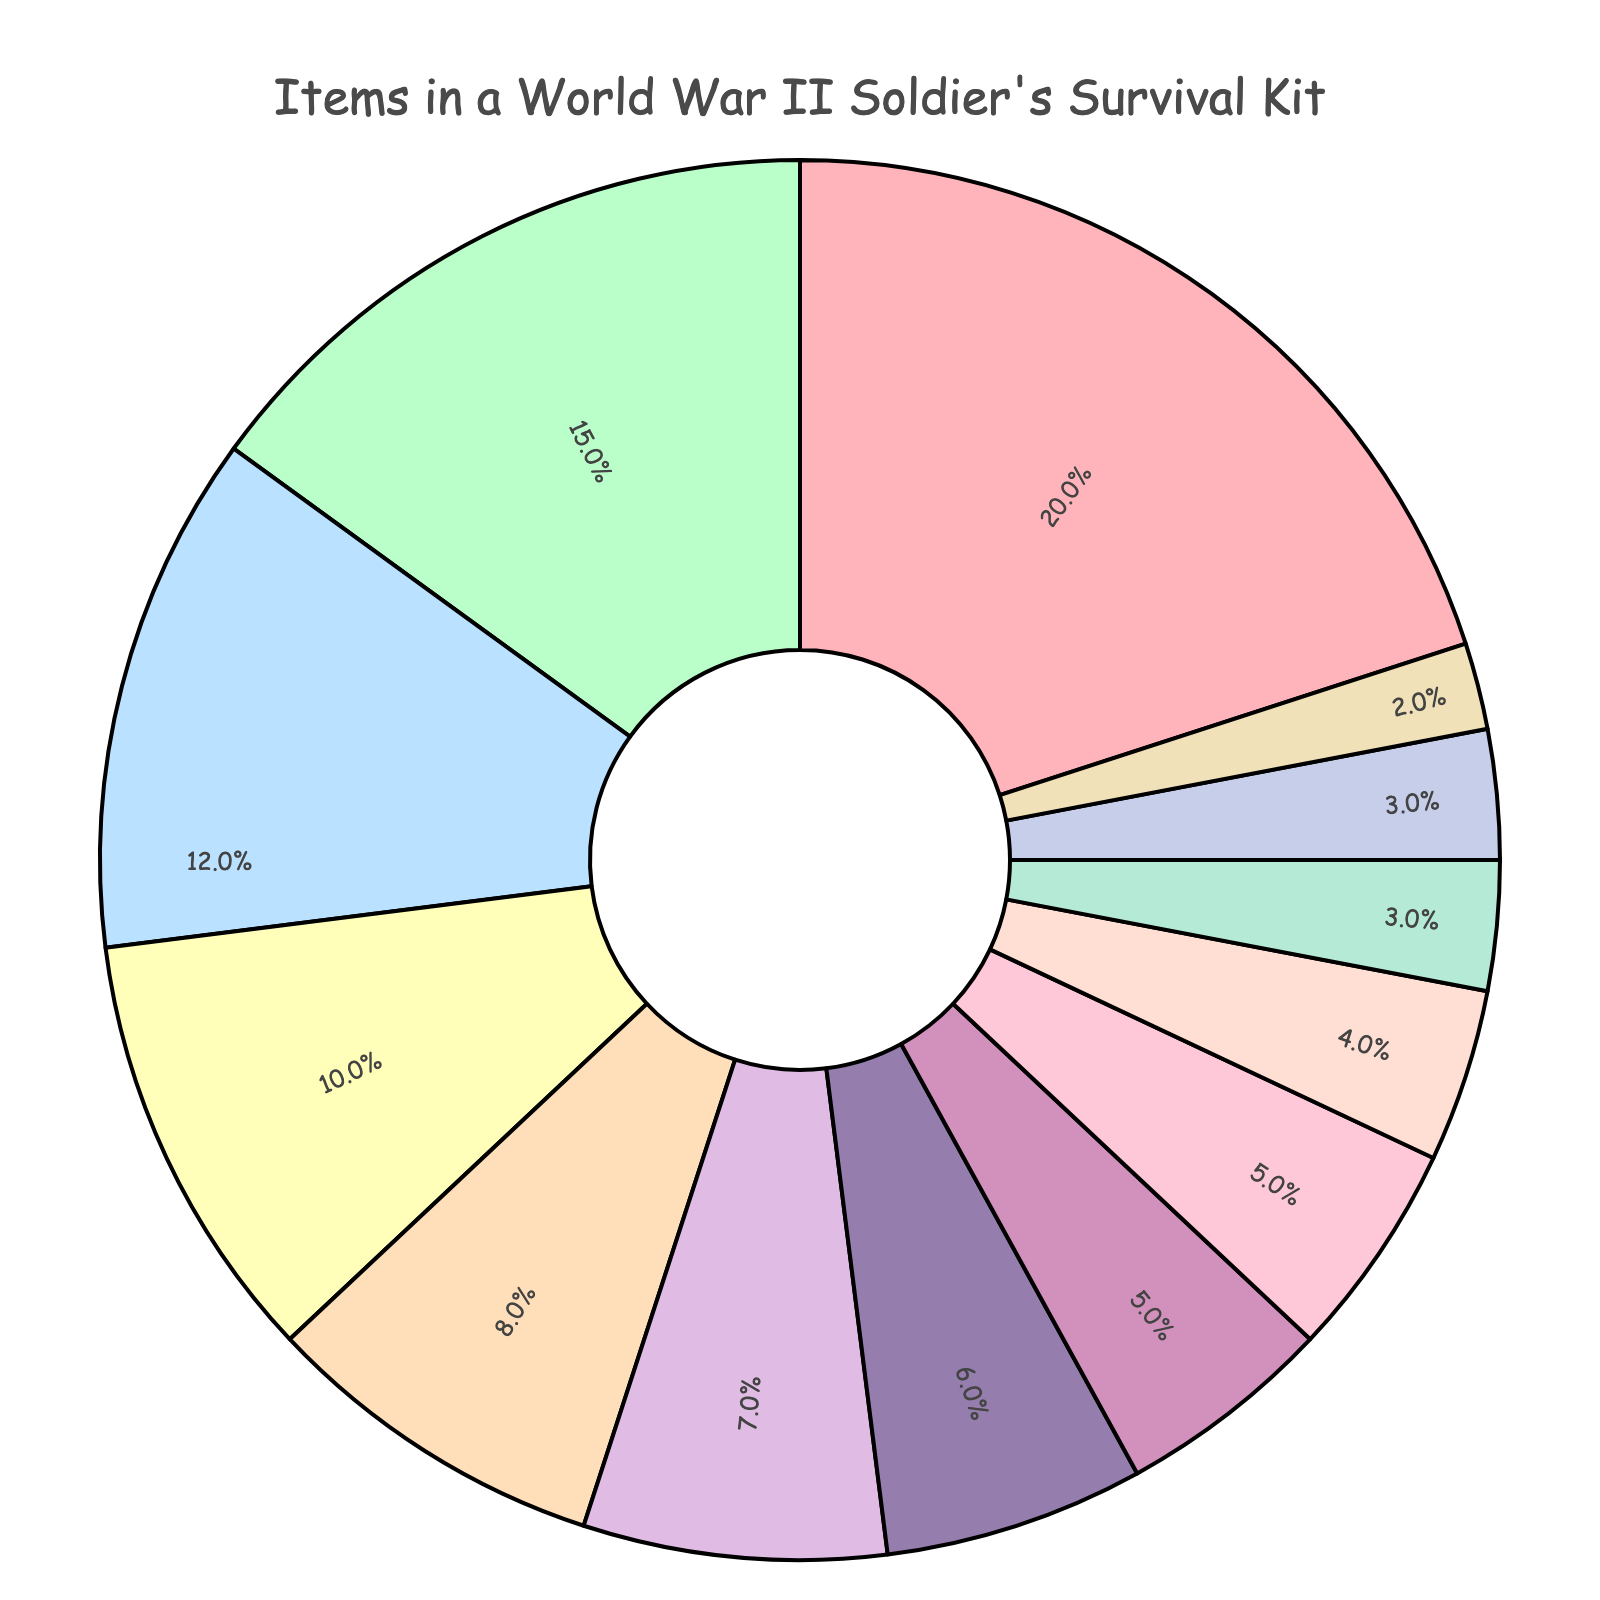What item has the highest percentage in the survival kit? The item with the highest percentage is determined by observing the largest section of the pie chart. "Water purification tablets" is the largest section.
Answer: Water purification tablets Which item has a higher percentage: Compass or Flashlight? Locate both "Compass" and "Flashlight" on the pie chart and compare their sizes. "Compass" is at 10%, and "Flashlight" is at 7%, making "Compass" higher.
Answer: Compass What is the combined percentage for the First aid kit and Matches? Sum the percentages for "First aid kit" which is 15% and "Matches" which is 8%. 15% + 8% = 23%.
Answer: 23% Which category has the lowest percentage value? Find the smallest slice in the pie chart, which represents "Iodine tablets" at 2%.
Answer: Iodine tablets How much larger is the percentage of Water purification tablets compared to the Multi-tool knife? Subtract the percentage of "Multi-tool knife" (5%) from the percentage of "Water purification tablets" (20%). 20% - 5% = 15%.
Answer: 15% What items have a percentage value less than 5%? Identify the slices in the pie chart smaller than 5%. These are "Signal mirror" (4%), "Sewing kit" (3%), "Emergency blanket" (3%), and "Iodine tablets" (2%).
Answer: Signal mirror, Sewing kit, Emergency blanket, Iodine tablets What is the percentage difference between Canned rations and Bandages? Subtract the percentage of "Bandages" (6%) from "Canned rations" (12%). 12% - 6% = 6%.
Answer: 6% Compare the total percentage of items labeled as blankets (Emergency blanket) and tools (Multi-tool knife, Paracord). Sum the percentages for "Emergency blanket" (3%), "Multi-tool knife" (5%), and "Paracord" (5%). The combined total is 3% + 5% + 5% = 13%.
Answer: 13% 